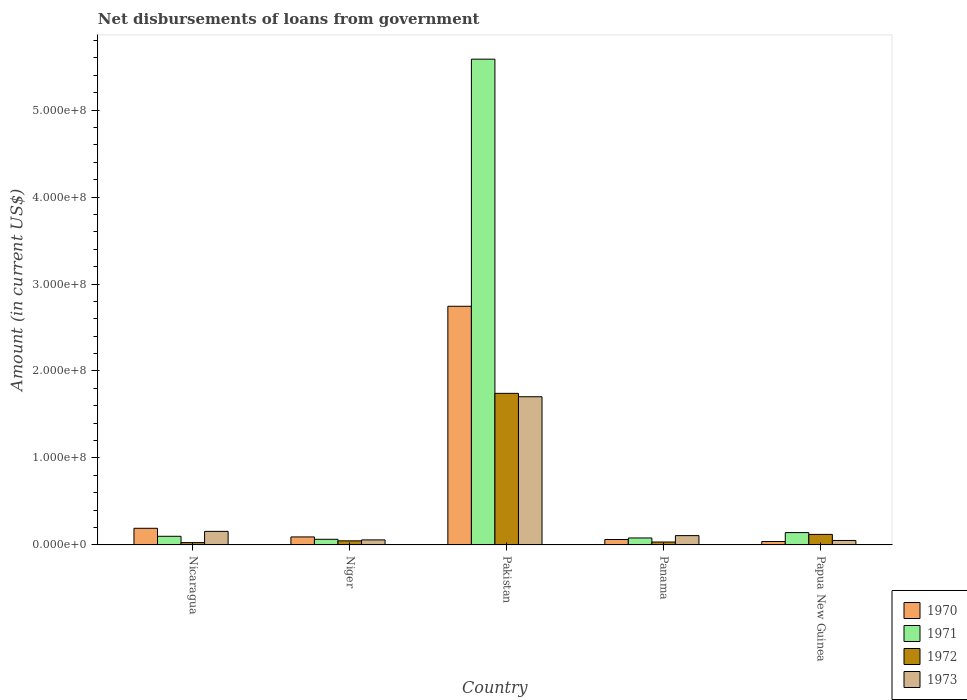Are the number of bars per tick equal to the number of legend labels?
Offer a very short reply. Yes. How many bars are there on the 1st tick from the left?
Your answer should be very brief. 4. How many bars are there on the 5th tick from the right?
Your answer should be very brief. 4. What is the label of the 1st group of bars from the left?
Offer a terse response. Nicaragua. In how many cases, is the number of bars for a given country not equal to the number of legend labels?
Your answer should be compact. 0. What is the amount of loan disbursed from government in 1972 in Panama?
Your answer should be very brief. 3.34e+06. Across all countries, what is the maximum amount of loan disbursed from government in 1973?
Give a very brief answer. 1.70e+08. Across all countries, what is the minimum amount of loan disbursed from government in 1972?
Offer a very short reply. 2.70e+06. In which country was the amount of loan disbursed from government in 1971 maximum?
Your answer should be very brief. Pakistan. In which country was the amount of loan disbursed from government in 1971 minimum?
Ensure brevity in your answer.  Niger. What is the total amount of loan disbursed from government in 1970 in the graph?
Offer a very short reply. 3.13e+08. What is the difference between the amount of loan disbursed from government in 1971 in Nicaragua and that in Papua New Guinea?
Make the answer very short. -4.26e+06. What is the difference between the amount of loan disbursed from government in 1971 in Nicaragua and the amount of loan disbursed from government in 1973 in Pakistan?
Offer a very short reply. -1.60e+08. What is the average amount of loan disbursed from government in 1972 per country?
Offer a terse response. 3.94e+07. What is the difference between the amount of loan disbursed from government of/in 1972 and amount of loan disbursed from government of/in 1973 in Nicaragua?
Make the answer very short. -1.29e+07. What is the ratio of the amount of loan disbursed from government in 1972 in Nicaragua to that in Panama?
Provide a succinct answer. 0.81. What is the difference between the highest and the second highest amount of loan disbursed from government in 1971?
Provide a succinct answer. 5.49e+08. What is the difference between the highest and the lowest amount of loan disbursed from government in 1973?
Offer a very short reply. 1.65e+08. In how many countries, is the amount of loan disbursed from government in 1972 greater than the average amount of loan disbursed from government in 1972 taken over all countries?
Give a very brief answer. 1. Is the sum of the amount of loan disbursed from government in 1970 in Nicaragua and Niger greater than the maximum amount of loan disbursed from government in 1973 across all countries?
Give a very brief answer. No. Is it the case that in every country, the sum of the amount of loan disbursed from government in 1971 and amount of loan disbursed from government in 1973 is greater than the sum of amount of loan disbursed from government in 1970 and amount of loan disbursed from government in 1972?
Give a very brief answer. No. How many bars are there?
Provide a succinct answer. 20. Are all the bars in the graph horizontal?
Provide a succinct answer. No. Does the graph contain any zero values?
Your answer should be compact. No. Does the graph contain grids?
Provide a succinct answer. No. Where does the legend appear in the graph?
Your response must be concise. Bottom right. How many legend labels are there?
Ensure brevity in your answer.  4. How are the legend labels stacked?
Provide a succinct answer. Vertical. What is the title of the graph?
Your answer should be compact. Net disbursements of loans from government. What is the Amount (in current US$) in 1970 in Nicaragua?
Give a very brief answer. 1.91e+07. What is the Amount (in current US$) in 1971 in Nicaragua?
Provide a short and direct response. 9.93e+06. What is the Amount (in current US$) in 1972 in Nicaragua?
Ensure brevity in your answer.  2.70e+06. What is the Amount (in current US$) in 1973 in Nicaragua?
Give a very brief answer. 1.56e+07. What is the Amount (in current US$) of 1970 in Niger?
Your response must be concise. 9.21e+06. What is the Amount (in current US$) of 1971 in Niger?
Ensure brevity in your answer.  6.50e+06. What is the Amount (in current US$) of 1972 in Niger?
Ensure brevity in your answer.  4.70e+06. What is the Amount (in current US$) of 1973 in Niger?
Keep it short and to the point. 5.79e+06. What is the Amount (in current US$) in 1970 in Pakistan?
Make the answer very short. 2.74e+08. What is the Amount (in current US$) of 1971 in Pakistan?
Offer a very short reply. 5.59e+08. What is the Amount (in current US$) of 1972 in Pakistan?
Offer a terse response. 1.74e+08. What is the Amount (in current US$) of 1973 in Pakistan?
Provide a short and direct response. 1.70e+08. What is the Amount (in current US$) in 1970 in Panama?
Your answer should be very brief. 6.24e+06. What is the Amount (in current US$) in 1971 in Panama?
Give a very brief answer. 8.01e+06. What is the Amount (in current US$) in 1972 in Panama?
Your answer should be very brief. 3.34e+06. What is the Amount (in current US$) of 1973 in Panama?
Your answer should be very brief. 1.07e+07. What is the Amount (in current US$) in 1970 in Papua New Guinea?
Your response must be concise. 3.92e+06. What is the Amount (in current US$) of 1971 in Papua New Guinea?
Give a very brief answer. 1.42e+07. What is the Amount (in current US$) of 1972 in Papua New Guinea?
Give a very brief answer. 1.21e+07. What is the Amount (in current US$) in 1973 in Papua New Guinea?
Your response must be concise. 5.14e+06. Across all countries, what is the maximum Amount (in current US$) in 1970?
Provide a succinct answer. 2.74e+08. Across all countries, what is the maximum Amount (in current US$) of 1971?
Offer a very short reply. 5.59e+08. Across all countries, what is the maximum Amount (in current US$) in 1972?
Keep it short and to the point. 1.74e+08. Across all countries, what is the maximum Amount (in current US$) of 1973?
Give a very brief answer. 1.70e+08. Across all countries, what is the minimum Amount (in current US$) of 1970?
Ensure brevity in your answer.  3.92e+06. Across all countries, what is the minimum Amount (in current US$) of 1971?
Make the answer very short. 6.50e+06. Across all countries, what is the minimum Amount (in current US$) in 1972?
Your answer should be compact. 2.70e+06. Across all countries, what is the minimum Amount (in current US$) of 1973?
Your answer should be very brief. 5.14e+06. What is the total Amount (in current US$) of 1970 in the graph?
Offer a terse response. 3.13e+08. What is the total Amount (in current US$) in 1971 in the graph?
Your response must be concise. 5.97e+08. What is the total Amount (in current US$) in 1972 in the graph?
Offer a very short reply. 1.97e+08. What is the total Amount (in current US$) in 1973 in the graph?
Offer a very short reply. 2.08e+08. What is the difference between the Amount (in current US$) in 1970 in Nicaragua and that in Niger?
Give a very brief answer. 9.94e+06. What is the difference between the Amount (in current US$) of 1971 in Nicaragua and that in Niger?
Provide a short and direct response. 3.44e+06. What is the difference between the Amount (in current US$) in 1972 in Nicaragua and that in Niger?
Ensure brevity in your answer.  -2.00e+06. What is the difference between the Amount (in current US$) of 1973 in Nicaragua and that in Niger?
Your answer should be very brief. 9.80e+06. What is the difference between the Amount (in current US$) in 1970 in Nicaragua and that in Pakistan?
Provide a succinct answer. -2.55e+08. What is the difference between the Amount (in current US$) of 1971 in Nicaragua and that in Pakistan?
Ensure brevity in your answer.  -5.49e+08. What is the difference between the Amount (in current US$) of 1972 in Nicaragua and that in Pakistan?
Provide a succinct answer. -1.72e+08. What is the difference between the Amount (in current US$) in 1973 in Nicaragua and that in Pakistan?
Ensure brevity in your answer.  -1.55e+08. What is the difference between the Amount (in current US$) of 1970 in Nicaragua and that in Panama?
Your answer should be very brief. 1.29e+07. What is the difference between the Amount (in current US$) of 1971 in Nicaragua and that in Panama?
Your response must be concise. 1.92e+06. What is the difference between the Amount (in current US$) of 1972 in Nicaragua and that in Panama?
Make the answer very short. -6.45e+05. What is the difference between the Amount (in current US$) of 1973 in Nicaragua and that in Panama?
Give a very brief answer. 4.89e+06. What is the difference between the Amount (in current US$) in 1970 in Nicaragua and that in Papua New Guinea?
Provide a short and direct response. 1.52e+07. What is the difference between the Amount (in current US$) of 1971 in Nicaragua and that in Papua New Guinea?
Keep it short and to the point. -4.26e+06. What is the difference between the Amount (in current US$) of 1972 in Nicaragua and that in Papua New Guinea?
Your answer should be compact. -9.40e+06. What is the difference between the Amount (in current US$) of 1973 in Nicaragua and that in Papua New Guinea?
Keep it short and to the point. 1.05e+07. What is the difference between the Amount (in current US$) in 1970 in Niger and that in Pakistan?
Give a very brief answer. -2.65e+08. What is the difference between the Amount (in current US$) of 1971 in Niger and that in Pakistan?
Offer a very short reply. -5.52e+08. What is the difference between the Amount (in current US$) in 1972 in Niger and that in Pakistan?
Keep it short and to the point. -1.70e+08. What is the difference between the Amount (in current US$) of 1973 in Niger and that in Pakistan?
Your response must be concise. -1.65e+08. What is the difference between the Amount (in current US$) in 1970 in Niger and that in Panama?
Your answer should be compact. 2.96e+06. What is the difference between the Amount (in current US$) of 1971 in Niger and that in Panama?
Your answer should be compact. -1.51e+06. What is the difference between the Amount (in current US$) of 1972 in Niger and that in Panama?
Offer a very short reply. 1.36e+06. What is the difference between the Amount (in current US$) of 1973 in Niger and that in Panama?
Provide a succinct answer. -4.91e+06. What is the difference between the Amount (in current US$) of 1970 in Niger and that in Papua New Guinea?
Offer a very short reply. 5.29e+06. What is the difference between the Amount (in current US$) of 1971 in Niger and that in Papua New Guinea?
Ensure brevity in your answer.  -7.70e+06. What is the difference between the Amount (in current US$) in 1972 in Niger and that in Papua New Guinea?
Ensure brevity in your answer.  -7.40e+06. What is the difference between the Amount (in current US$) in 1973 in Niger and that in Papua New Guinea?
Ensure brevity in your answer.  6.53e+05. What is the difference between the Amount (in current US$) in 1970 in Pakistan and that in Panama?
Give a very brief answer. 2.68e+08. What is the difference between the Amount (in current US$) in 1971 in Pakistan and that in Panama?
Offer a terse response. 5.51e+08. What is the difference between the Amount (in current US$) in 1972 in Pakistan and that in Panama?
Your answer should be compact. 1.71e+08. What is the difference between the Amount (in current US$) in 1973 in Pakistan and that in Panama?
Make the answer very short. 1.60e+08. What is the difference between the Amount (in current US$) of 1970 in Pakistan and that in Papua New Guinea?
Ensure brevity in your answer.  2.70e+08. What is the difference between the Amount (in current US$) in 1971 in Pakistan and that in Papua New Guinea?
Your answer should be compact. 5.44e+08. What is the difference between the Amount (in current US$) in 1972 in Pakistan and that in Papua New Guinea?
Provide a short and direct response. 1.62e+08. What is the difference between the Amount (in current US$) in 1973 in Pakistan and that in Papua New Guinea?
Your response must be concise. 1.65e+08. What is the difference between the Amount (in current US$) of 1970 in Panama and that in Papua New Guinea?
Offer a very short reply. 2.32e+06. What is the difference between the Amount (in current US$) of 1971 in Panama and that in Papua New Guinea?
Your answer should be very brief. -6.19e+06. What is the difference between the Amount (in current US$) of 1972 in Panama and that in Papua New Guinea?
Provide a succinct answer. -8.76e+06. What is the difference between the Amount (in current US$) in 1973 in Panama and that in Papua New Guinea?
Offer a very short reply. 5.56e+06. What is the difference between the Amount (in current US$) of 1970 in Nicaragua and the Amount (in current US$) of 1971 in Niger?
Keep it short and to the point. 1.26e+07. What is the difference between the Amount (in current US$) of 1970 in Nicaragua and the Amount (in current US$) of 1972 in Niger?
Offer a terse response. 1.44e+07. What is the difference between the Amount (in current US$) in 1970 in Nicaragua and the Amount (in current US$) in 1973 in Niger?
Ensure brevity in your answer.  1.34e+07. What is the difference between the Amount (in current US$) of 1971 in Nicaragua and the Amount (in current US$) of 1972 in Niger?
Give a very brief answer. 5.23e+06. What is the difference between the Amount (in current US$) in 1971 in Nicaragua and the Amount (in current US$) in 1973 in Niger?
Give a very brief answer. 4.14e+06. What is the difference between the Amount (in current US$) in 1972 in Nicaragua and the Amount (in current US$) in 1973 in Niger?
Your answer should be compact. -3.09e+06. What is the difference between the Amount (in current US$) of 1970 in Nicaragua and the Amount (in current US$) of 1971 in Pakistan?
Ensure brevity in your answer.  -5.39e+08. What is the difference between the Amount (in current US$) of 1970 in Nicaragua and the Amount (in current US$) of 1972 in Pakistan?
Ensure brevity in your answer.  -1.55e+08. What is the difference between the Amount (in current US$) in 1970 in Nicaragua and the Amount (in current US$) in 1973 in Pakistan?
Provide a succinct answer. -1.51e+08. What is the difference between the Amount (in current US$) of 1971 in Nicaragua and the Amount (in current US$) of 1972 in Pakistan?
Provide a short and direct response. -1.64e+08. What is the difference between the Amount (in current US$) in 1971 in Nicaragua and the Amount (in current US$) in 1973 in Pakistan?
Your answer should be compact. -1.60e+08. What is the difference between the Amount (in current US$) in 1972 in Nicaragua and the Amount (in current US$) in 1973 in Pakistan?
Give a very brief answer. -1.68e+08. What is the difference between the Amount (in current US$) of 1970 in Nicaragua and the Amount (in current US$) of 1971 in Panama?
Offer a terse response. 1.11e+07. What is the difference between the Amount (in current US$) in 1970 in Nicaragua and the Amount (in current US$) in 1972 in Panama?
Your answer should be compact. 1.58e+07. What is the difference between the Amount (in current US$) in 1970 in Nicaragua and the Amount (in current US$) in 1973 in Panama?
Your response must be concise. 8.44e+06. What is the difference between the Amount (in current US$) of 1971 in Nicaragua and the Amount (in current US$) of 1972 in Panama?
Make the answer very short. 6.59e+06. What is the difference between the Amount (in current US$) in 1971 in Nicaragua and the Amount (in current US$) in 1973 in Panama?
Provide a short and direct response. -7.67e+05. What is the difference between the Amount (in current US$) of 1972 in Nicaragua and the Amount (in current US$) of 1973 in Panama?
Keep it short and to the point. -8.00e+06. What is the difference between the Amount (in current US$) in 1970 in Nicaragua and the Amount (in current US$) in 1971 in Papua New Guinea?
Your response must be concise. 4.95e+06. What is the difference between the Amount (in current US$) in 1970 in Nicaragua and the Amount (in current US$) in 1972 in Papua New Guinea?
Provide a short and direct response. 7.04e+06. What is the difference between the Amount (in current US$) in 1970 in Nicaragua and the Amount (in current US$) in 1973 in Papua New Guinea?
Keep it short and to the point. 1.40e+07. What is the difference between the Amount (in current US$) of 1971 in Nicaragua and the Amount (in current US$) of 1972 in Papua New Guinea?
Your answer should be compact. -2.17e+06. What is the difference between the Amount (in current US$) of 1971 in Nicaragua and the Amount (in current US$) of 1973 in Papua New Guinea?
Give a very brief answer. 4.80e+06. What is the difference between the Amount (in current US$) in 1972 in Nicaragua and the Amount (in current US$) in 1973 in Papua New Guinea?
Give a very brief answer. -2.44e+06. What is the difference between the Amount (in current US$) in 1970 in Niger and the Amount (in current US$) in 1971 in Pakistan?
Ensure brevity in your answer.  -5.49e+08. What is the difference between the Amount (in current US$) of 1970 in Niger and the Amount (in current US$) of 1972 in Pakistan?
Offer a very short reply. -1.65e+08. What is the difference between the Amount (in current US$) in 1970 in Niger and the Amount (in current US$) in 1973 in Pakistan?
Your answer should be compact. -1.61e+08. What is the difference between the Amount (in current US$) of 1971 in Niger and the Amount (in current US$) of 1972 in Pakistan?
Your answer should be compact. -1.68e+08. What is the difference between the Amount (in current US$) of 1971 in Niger and the Amount (in current US$) of 1973 in Pakistan?
Ensure brevity in your answer.  -1.64e+08. What is the difference between the Amount (in current US$) of 1972 in Niger and the Amount (in current US$) of 1973 in Pakistan?
Your response must be concise. -1.66e+08. What is the difference between the Amount (in current US$) of 1970 in Niger and the Amount (in current US$) of 1971 in Panama?
Provide a succinct answer. 1.20e+06. What is the difference between the Amount (in current US$) of 1970 in Niger and the Amount (in current US$) of 1972 in Panama?
Your answer should be very brief. 5.86e+06. What is the difference between the Amount (in current US$) of 1970 in Niger and the Amount (in current US$) of 1973 in Panama?
Provide a short and direct response. -1.50e+06. What is the difference between the Amount (in current US$) of 1971 in Niger and the Amount (in current US$) of 1972 in Panama?
Your answer should be compact. 3.15e+06. What is the difference between the Amount (in current US$) in 1971 in Niger and the Amount (in current US$) in 1973 in Panama?
Make the answer very short. -4.21e+06. What is the difference between the Amount (in current US$) in 1972 in Niger and the Amount (in current US$) in 1973 in Panama?
Provide a succinct answer. -6.00e+06. What is the difference between the Amount (in current US$) of 1970 in Niger and the Amount (in current US$) of 1971 in Papua New Guinea?
Make the answer very short. -4.99e+06. What is the difference between the Amount (in current US$) of 1970 in Niger and the Amount (in current US$) of 1972 in Papua New Guinea?
Give a very brief answer. -2.90e+06. What is the difference between the Amount (in current US$) in 1970 in Niger and the Amount (in current US$) in 1973 in Papua New Guinea?
Offer a terse response. 4.07e+06. What is the difference between the Amount (in current US$) of 1971 in Niger and the Amount (in current US$) of 1972 in Papua New Guinea?
Ensure brevity in your answer.  -5.61e+06. What is the difference between the Amount (in current US$) of 1971 in Niger and the Amount (in current US$) of 1973 in Papua New Guinea?
Make the answer very short. 1.36e+06. What is the difference between the Amount (in current US$) in 1972 in Niger and the Amount (in current US$) in 1973 in Papua New Guinea?
Provide a short and direct response. -4.35e+05. What is the difference between the Amount (in current US$) of 1970 in Pakistan and the Amount (in current US$) of 1971 in Panama?
Offer a terse response. 2.66e+08. What is the difference between the Amount (in current US$) in 1970 in Pakistan and the Amount (in current US$) in 1972 in Panama?
Make the answer very short. 2.71e+08. What is the difference between the Amount (in current US$) in 1970 in Pakistan and the Amount (in current US$) in 1973 in Panama?
Provide a short and direct response. 2.64e+08. What is the difference between the Amount (in current US$) in 1971 in Pakistan and the Amount (in current US$) in 1972 in Panama?
Provide a short and direct response. 5.55e+08. What is the difference between the Amount (in current US$) in 1971 in Pakistan and the Amount (in current US$) in 1973 in Panama?
Give a very brief answer. 5.48e+08. What is the difference between the Amount (in current US$) of 1972 in Pakistan and the Amount (in current US$) of 1973 in Panama?
Your answer should be very brief. 1.64e+08. What is the difference between the Amount (in current US$) of 1970 in Pakistan and the Amount (in current US$) of 1971 in Papua New Guinea?
Your answer should be compact. 2.60e+08. What is the difference between the Amount (in current US$) in 1970 in Pakistan and the Amount (in current US$) in 1972 in Papua New Guinea?
Provide a short and direct response. 2.62e+08. What is the difference between the Amount (in current US$) in 1970 in Pakistan and the Amount (in current US$) in 1973 in Papua New Guinea?
Give a very brief answer. 2.69e+08. What is the difference between the Amount (in current US$) of 1971 in Pakistan and the Amount (in current US$) of 1972 in Papua New Guinea?
Make the answer very short. 5.46e+08. What is the difference between the Amount (in current US$) in 1971 in Pakistan and the Amount (in current US$) in 1973 in Papua New Guinea?
Give a very brief answer. 5.53e+08. What is the difference between the Amount (in current US$) in 1972 in Pakistan and the Amount (in current US$) in 1973 in Papua New Guinea?
Give a very brief answer. 1.69e+08. What is the difference between the Amount (in current US$) of 1970 in Panama and the Amount (in current US$) of 1971 in Papua New Guinea?
Your answer should be very brief. -7.96e+06. What is the difference between the Amount (in current US$) of 1970 in Panama and the Amount (in current US$) of 1972 in Papua New Guinea?
Provide a succinct answer. -5.86e+06. What is the difference between the Amount (in current US$) in 1970 in Panama and the Amount (in current US$) in 1973 in Papua New Guinea?
Make the answer very short. 1.10e+06. What is the difference between the Amount (in current US$) of 1971 in Panama and the Amount (in current US$) of 1972 in Papua New Guinea?
Provide a short and direct response. -4.09e+06. What is the difference between the Amount (in current US$) of 1971 in Panama and the Amount (in current US$) of 1973 in Papua New Guinea?
Give a very brief answer. 2.87e+06. What is the difference between the Amount (in current US$) of 1972 in Panama and the Amount (in current US$) of 1973 in Papua New Guinea?
Provide a succinct answer. -1.79e+06. What is the average Amount (in current US$) of 1970 per country?
Provide a succinct answer. 6.26e+07. What is the average Amount (in current US$) of 1971 per country?
Your answer should be compact. 1.19e+08. What is the average Amount (in current US$) of 1972 per country?
Your response must be concise. 3.94e+07. What is the average Amount (in current US$) of 1973 per country?
Make the answer very short. 4.15e+07. What is the difference between the Amount (in current US$) in 1970 and Amount (in current US$) in 1971 in Nicaragua?
Your response must be concise. 9.21e+06. What is the difference between the Amount (in current US$) of 1970 and Amount (in current US$) of 1972 in Nicaragua?
Your response must be concise. 1.64e+07. What is the difference between the Amount (in current US$) of 1970 and Amount (in current US$) of 1973 in Nicaragua?
Your answer should be compact. 3.55e+06. What is the difference between the Amount (in current US$) in 1971 and Amount (in current US$) in 1972 in Nicaragua?
Offer a terse response. 7.23e+06. What is the difference between the Amount (in current US$) of 1971 and Amount (in current US$) of 1973 in Nicaragua?
Give a very brief answer. -5.66e+06. What is the difference between the Amount (in current US$) in 1972 and Amount (in current US$) in 1973 in Nicaragua?
Provide a succinct answer. -1.29e+07. What is the difference between the Amount (in current US$) of 1970 and Amount (in current US$) of 1971 in Niger?
Provide a short and direct response. 2.71e+06. What is the difference between the Amount (in current US$) of 1970 and Amount (in current US$) of 1972 in Niger?
Your answer should be compact. 4.50e+06. What is the difference between the Amount (in current US$) of 1970 and Amount (in current US$) of 1973 in Niger?
Offer a very short reply. 3.42e+06. What is the difference between the Amount (in current US$) in 1971 and Amount (in current US$) in 1972 in Niger?
Give a very brief answer. 1.79e+06. What is the difference between the Amount (in current US$) in 1971 and Amount (in current US$) in 1973 in Niger?
Your response must be concise. 7.04e+05. What is the difference between the Amount (in current US$) in 1972 and Amount (in current US$) in 1973 in Niger?
Provide a succinct answer. -1.09e+06. What is the difference between the Amount (in current US$) of 1970 and Amount (in current US$) of 1971 in Pakistan?
Your response must be concise. -2.84e+08. What is the difference between the Amount (in current US$) of 1970 and Amount (in current US$) of 1972 in Pakistan?
Offer a very short reply. 1.00e+08. What is the difference between the Amount (in current US$) of 1970 and Amount (in current US$) of 1973 in Pakistan?
Ensure brevity in your answer.  1.04e+08. What is the difference between the Amount (in current US$) of 1971 and Amount (in current US$) of 1972 in Pakistan?
Keep it short and to the point. 3.84e+08. What is the difference between the Amount (in current US$) in 1971 and Amount (in current US$) in 1973 in Pakistan?
Offer a very short reply. 3.88e+08. What is the difference between the Amount (in current US$) of 1972 and Amount (in current US$) of 1973 in Pakistan?
Provide a succinct answer. 3.90e+06. What is the difference between the Amount (in current US$) in 1970 and Amount (in current US$) in 1971 in Panama?
Make the answer very short. -1.77e+06. What is the difference between the Amount (in current US$) of 1970 and Amount (in current US$) of 1972 in Panama?
Your response must be concise. 2.90e+06. What is the difference between the Amount (in current US$) in 1970 and Amount (in current US$) in 1973 in Panama?
Your response must be concise. -4.46e+06. What is the difference between the Amount (in current US$) in 1971 and Amount (in current US$) in 1972 in Panama?
Provide a succinct answer. 4.66e+06. What is the difference between the Amount (in current US$) of 1971 and Amount (in current US$) of 1973 in Panama?
Your response must be concise. -2.69e+06. What is the difference between the Amount (in current US$) in 1972 and Amount (in current US$) in 1973 in Panama?
Make the answer very short. -7.36e+06. What is the difference between the Amount (in current US$) of 1970 and Amount (in current US$) of 1971 in Papua New Guinea?
Keep it short and to the point. -1.03e+07. What is the difference between the Amount (in current US$) of 1970 and Amount (in current US$) of 1972 in Papua New Guinea?
Keep it short and to the point. -8.18e+06. What is the difference between the Amount (in current US$) of 1970 and Amount (in current US$) of 1973 in Papua New Guinea?
Your response must be concise. -1.22e+06. What is the difference between the Amount (in current US$) in 1971 and Amount (in current US$) in 1972 in Papua New Guinea?
Keep it short and to the point. 2.10e+06. What is the difference between the Amount (in current US$) in 1971 and Amount (in current US$) in 1973 in Papua New Guinea?
Provide a succinct answer. 9.06e+06. What is the difference between the Amount (in current US$) in 1972 and Amount (in current US$) in 1973 in Papua New Guinea?
Offer a terse response. 6.96e+06. What is the ratio of the Amount (in current US$) of 1970 in Nicaragua to that in Niger?
Ensure brevity in your answer.  2.08. What is the ratio of the Amount (in current US$) of 1971 in Nicaragua to that in Niger?
Your answer should be compact. 1.53. What is the ratio of the Amount (in current US$) in 1972 in Nicaragua to that in Niger?
Ensure brevity in your answer.  0.57. What is the ratio of the Amount (in current US$) in 1973 in Nicaragua to that in Niger?
Provide a succinct answer. 2.69. What is the ratio of the Amount (in current US$) in 1970 in Nicaragua to that in Pakistan?
Your answer should be very brief. 0.07. What is the ratio of the Amount (in current US$) in 1971 in Nicaragua to that in Pakistan?
Make the answer very short. 0.02. What is the ratio of the Amount (in current US$) in 1972 in Nicaragua to that in Pakistan?
Offer a very short reply. 0.02. What is the ratio of the Amount (in current US$) in 1973 in Nicaragua to that in Pakistan?
Provide a succinct answer. 0.09. What is the ratio of the Amount (in current US$) in 1970 in Nicaragua to that in Panama?
Make the answer very short. 3.07. What is the ratio of the Amount (in current US$) of 1971 in Nicaragua to that in Panama?
Offer a very short reply. 1.24. What is the ratio of the Amount (in current US$) of 1972 in Nicaragua to that in Panama?
Offer a terse response. 0.81. What is the ratio of the Amount (in current US$) of 1973 in Nicaragua to that in Panama?
Provide a succinct answer. 1.46. What is the ratio of the Amount (in current US$) in 1970 in Nicaragua to that in Papua New Guinea?
Offer a terse response. 4.88. What is the ratio of the Amount (in current US$) in 1971 in Nicaragua to that in Papua New Guinea?
Ensure brevity in your answer.  0.7. What is the ratio of the Amount (in current US$) in 1972 in Nicaragua to that in Papua New Guinea?
Provide a succinct answer. 0.22. What is the ratio of the Amount (in current US$) of 1973 in Nicaragua to that in Papua New Guinea?
Give a very brief answer. 3.03. What is the ratio of the Amount (in current US$) in 1970 in Niger to that in Pakistan?
Keep it short and to the point. 0.03. What is the ratio of the Amount (in current US$) of 1971 in Niger to that in Pakistan?
Give a very brief answer. 0.01. What is the ratio of the Amount (in current US$) in 1972 in Niger to that in Pakistan?
Your answer should be very brief. 0.03. What is the ratio of the Amount (in current US$) of 1973 in Niger to that in Pakistan?
Your response must be concise. 0.03. What is the ratio of the Amount (in current US$) of 1970 in Niger to that in Panama?
Provide a short and direct response. 1.48. What is the ratio of the Amount (in current US$) in 1971 in Niger to that in Panama?
Your response must be concise. 0.81. What is the ratio of the Amount (in current US$) of 1972 in Niger to that in Panama?
Provide a succinct answer. 1.41. What is the ratio of the Amount (in current US$) in 1973 in Niger to that in Panama?
Make the answer very short. 0.54. What is the ratio of the Amount (in current US$) in 1970 in Niger to that in Papua New Guinea?
Ensure brevity in your answer.  2.35. What is the ratio of the Amount (in current US$) in 1971 in Niger to that in Papua New Guinea?
Your answer should be compact. 0.46. What is the ratio of the Amount (in current US$) of 1972 in Niger to that in Papua New Guinea?
Provide a succinct answer. 0.39. What is the ratio of the Amount (in current US$) of 1973 in Niger to that in Papua New Guinea?
Ensure brevity in your answer.  1.13. What is the ratio of the Amount (in current US$) in 1970 in Pakistan to that in Panama?
Your answer should be very brief. 43.96. What is the ratio of the Amount (in current US$) of 1971 in Pakistan to that in Panama?
Your answer should be very brief. 69.73. What is the ratio of the Amount (in current US$) in 1972 in Pakistan to that in Panama?
Your answer should be very brief. 52.11. What is the ratio of the Amount (in current US$) in 1973 in Pakistan to that in Panama?
Provide a succinct answer. 15.92. What is the ratio of the Amount (in current US$) in 1970 in Pakistan to that in Papua New Guinea?
Offer a very short reply. 70. What is the ratio of the Amount (in current US$) in 1971 in Pakistan to that in Papua New Guinea?
Your answer should be compact. 39.34. What is the ratio of the Amount (in current US$) of 1972 in Pakistan to that in Papua New Guinea?
Provide a short and direct response. 14.4. What is the ratio of the Amount (in current US$) of 1973 in Pakistan to that in Papua New Guinea?
Ensure brevity in your answer.  33.16. What is the ratio of the Amount (in current US$) of 1970 in Panama to that in Papua New Guinea?
Your response must be concise. 1.59. What is the ratio of the Amount (in current US$) of 1971 in Panama to that in Papua New Guinea?
Provide a succinct answer. 0.56. What is the ratio of the Amount (in current US$) of 1972 in Panama to that in Papua New Guinea?
Provide a succinct answer. 0.28. What is the ratio of the Amount (in current US$) of 1973 in Panama to that in Papua New Guinea?
Keep it short and to the point. 2.08. What is the difference between the highest and the second highest Amount (in current US$) of 1970?
Make the answer very short. 2.55e+08. What is the difference between the highest and the second highest Amount (in current US$) in 1971?
Keep it short and to the point. 5.44e+08. What is the difference between the highest and the second highest Amount (in current US$) in 1972?
Make the answer very short. 1.62e+08. What is the difference between the highest and the second highest Amount (in current US$) of 1973?
Your answer should be compact. 1.55e+08. What is the difference between the highest and the lowest Amount (in current US$) of 1970?
Your answer should be very brief. 2.70e+08. What is the difference between the highest and the lowest Amount (in current US$) in 1971?
Your response must be concise. 5.52e+08. What is the difference between the highest and the lowest Amount (in current US$) of 1972?
Your answer should be very brief. 1.72e+08. What is the difference between the highest and the lowest Amount (in current US$) of 1973?
Your response must be concise. 1.65e+08. 